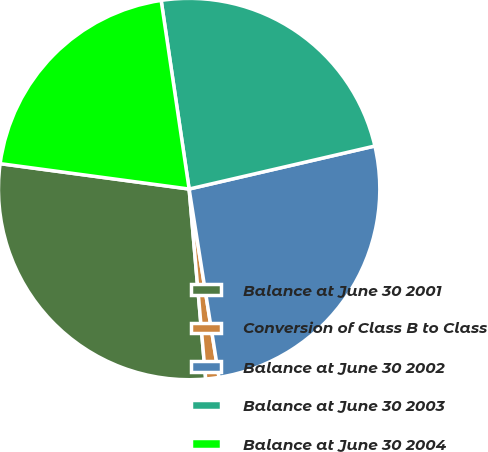Convert chart to OTSL. <chart><loc_0><loc_0><loc_500><loc_500><pie_chart><fcel>Balance at June 30 2001<fcel>Conversion of Class B to Class<fcel>Balance at June 30 2002<fcel>Balance at June 30 2003<fcel>Balance at June 30 2004<nl><fcel>28.51%<fcel>1.12%<fcel>26.12%<fcel>23.72%<fcel>20.53%<nl></chart> 